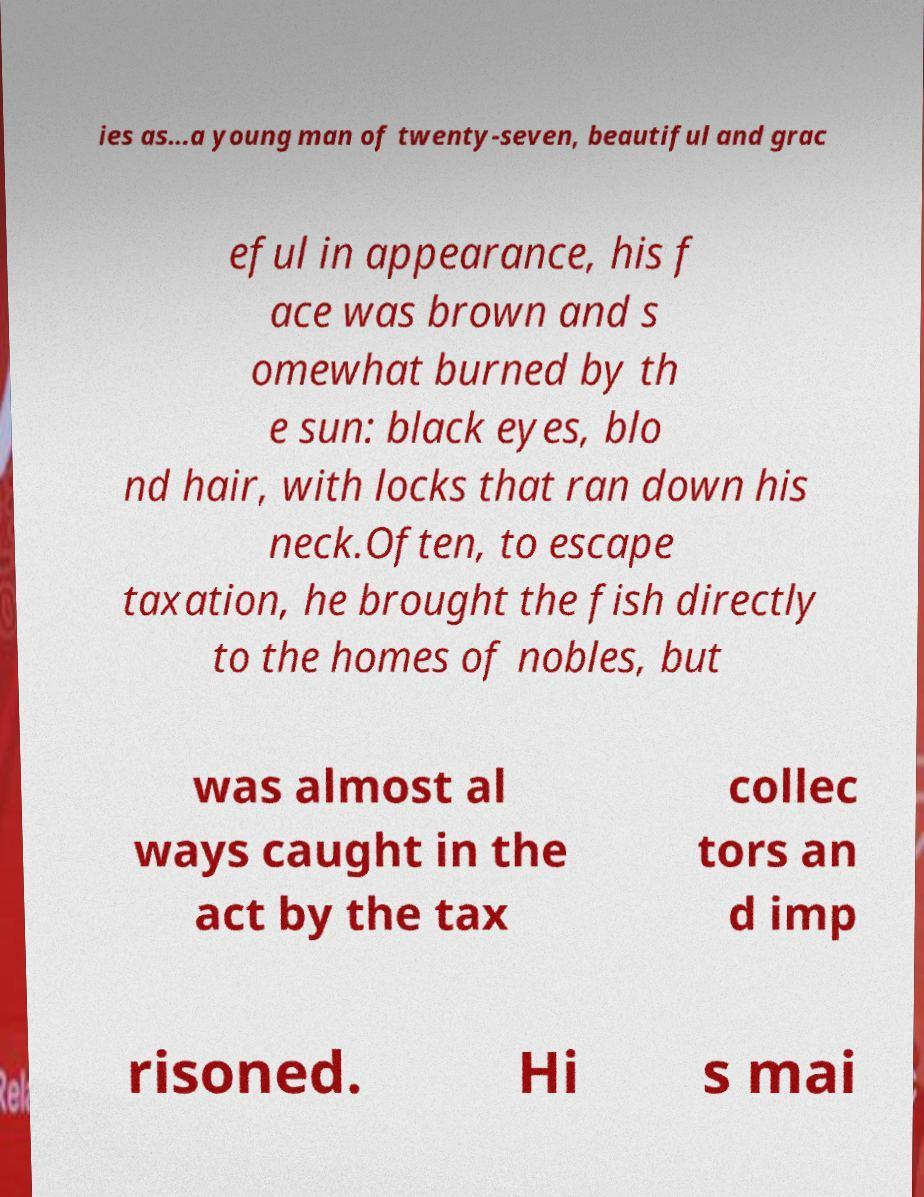Could you assist in decoding the text presented in this image and type it out clearly? ies as...a young man of twenty-seven, beautiful and grac eful in appearance, his f ace was brown and s omewhat burned by th e sun: black eyes, blo nd hair, with locks that ran down his neck.Often, to escape taxation, he brought the fish directly to the homes of nobles, but was almost al ways caught in the act by the tax collec tors an d imp risoned. Hi s mai 